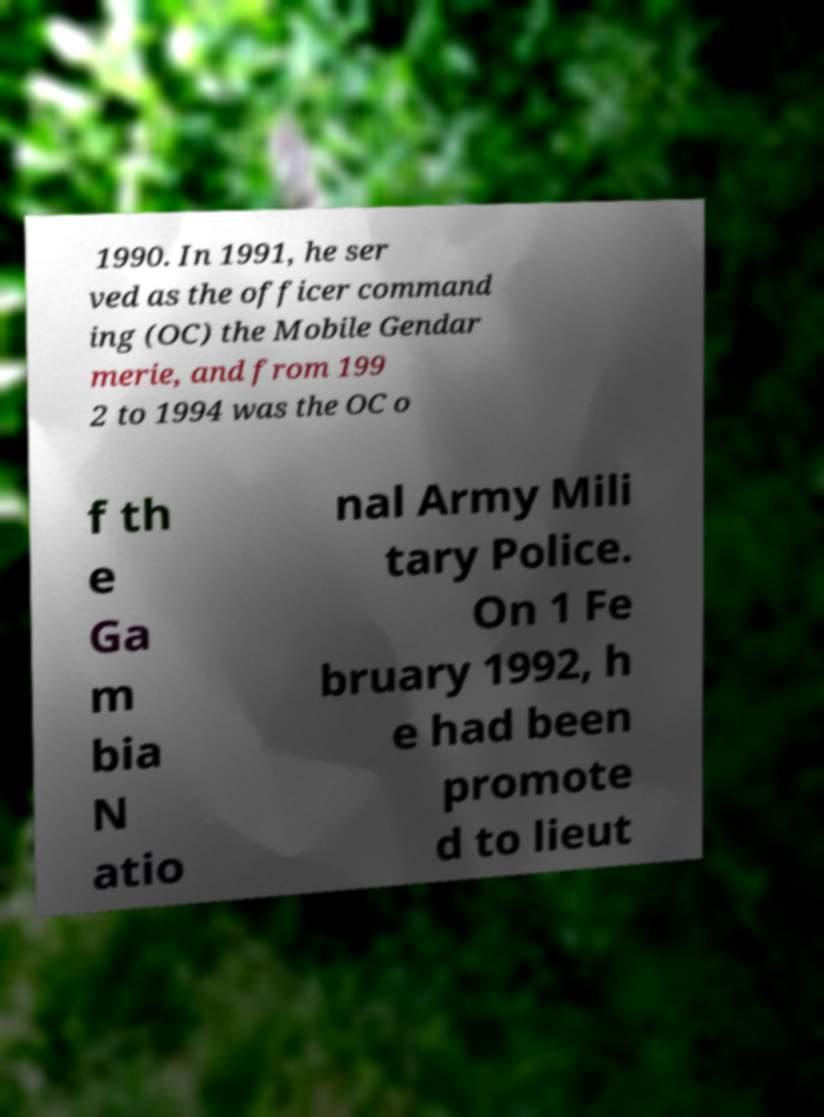Can you accurately transcribe the text from the provided image for me? 1990. In 1991, he ser ved as the officer command ing (OC) the Mobile Gendar merie, and from 199 2 to 1994 was the OC o f th e Ga m bia N atio nal Army Mili tary Police. On 1 Fe bruary 1992, h e had been promote d to lieut 